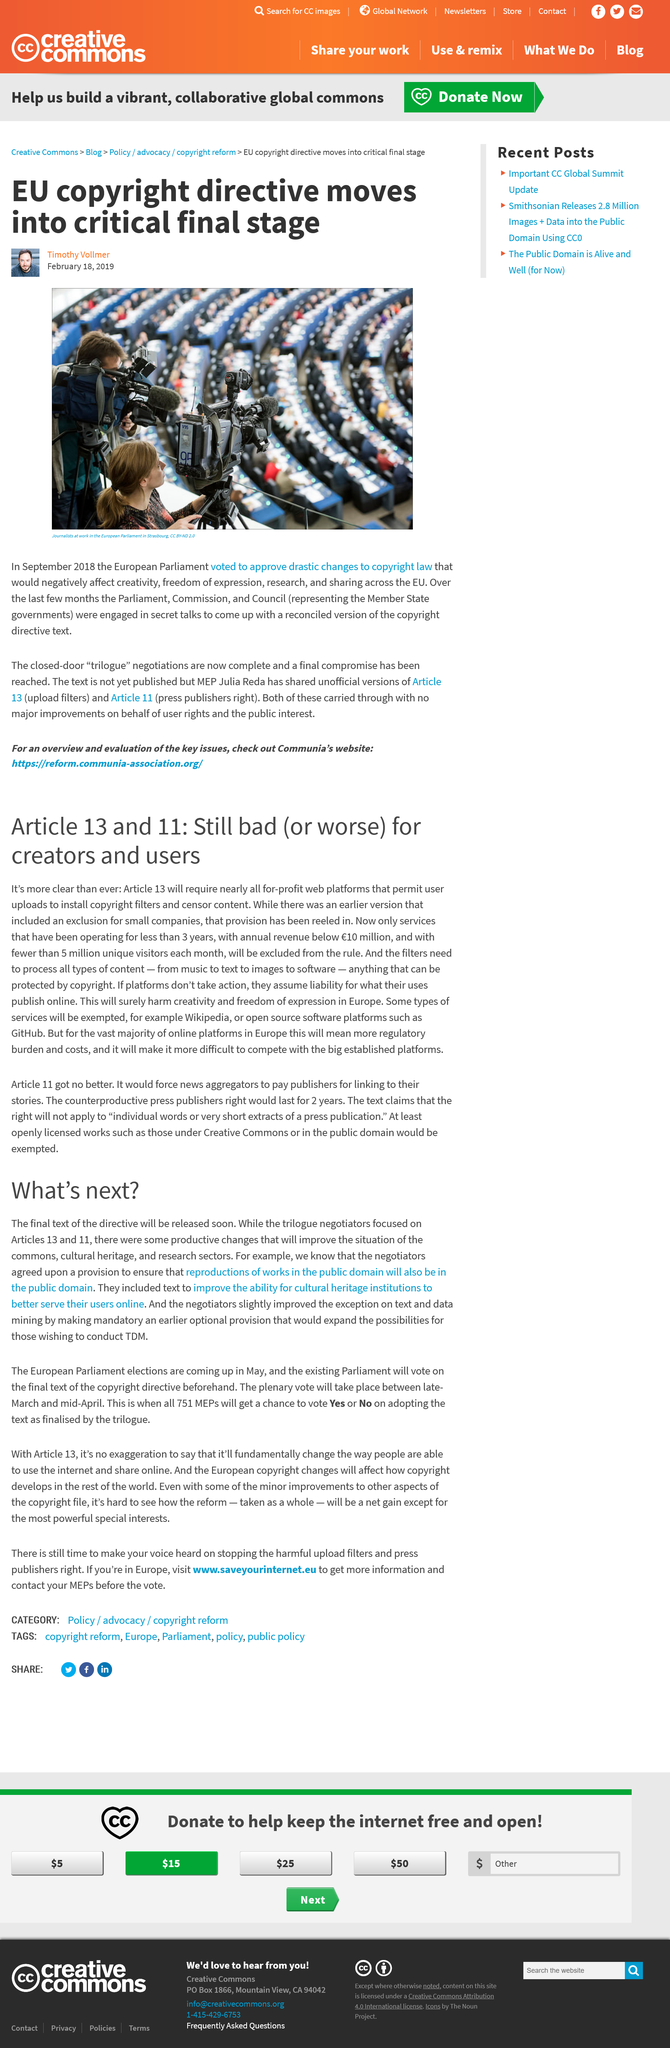Draw attention to some important aspects in this diagram. The title of this article is 'What is the title of this article?' and 'What's Next?' The Parliament, Commission, and Council are the three trilogue partners in the European Union. The articles 13 and 11 are supposedly unchanged according to reports. The European Parliament is located in Strasbourg. The trilogue negotiators primarily focused on Articles 13 and 11 during their negotiations. 